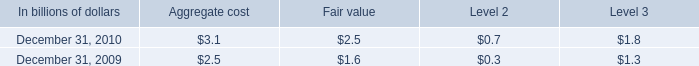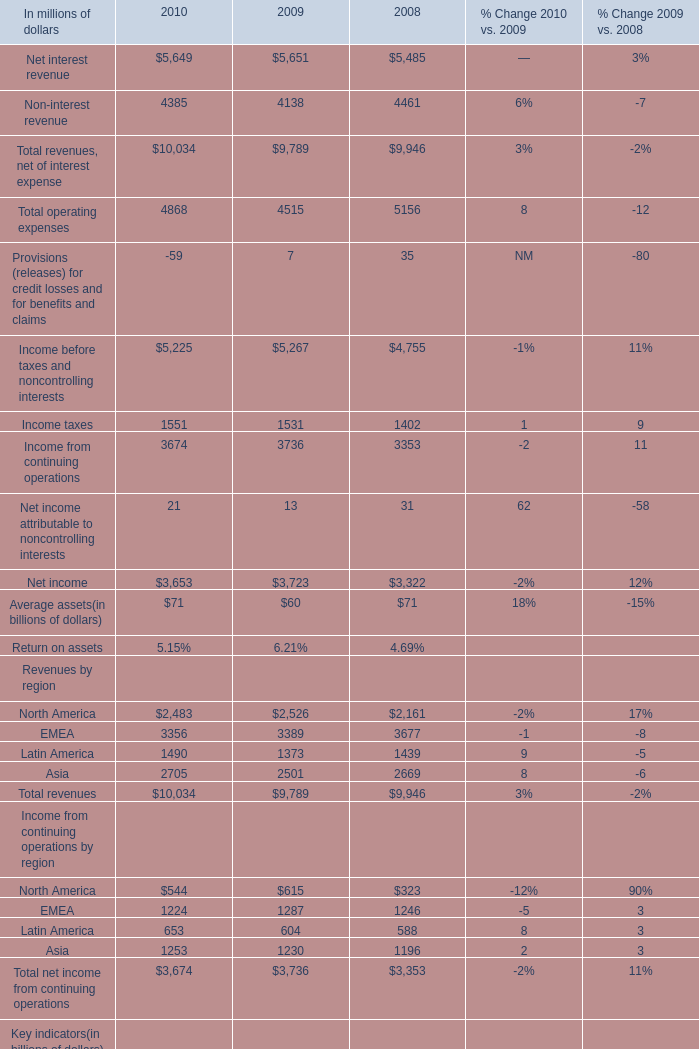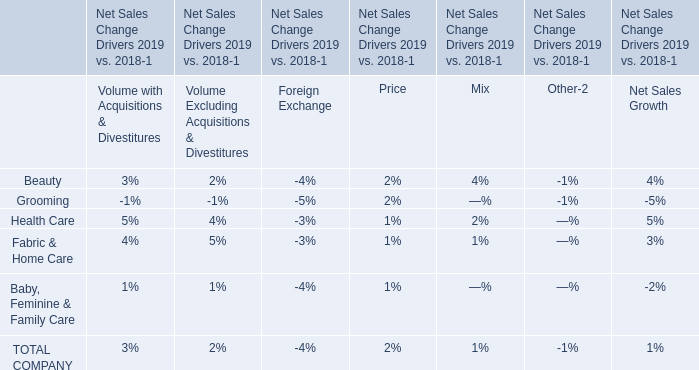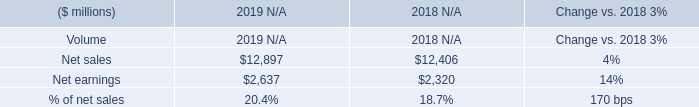Which year is Net interest revenue the most? (in million) 
Answer: 2009. 